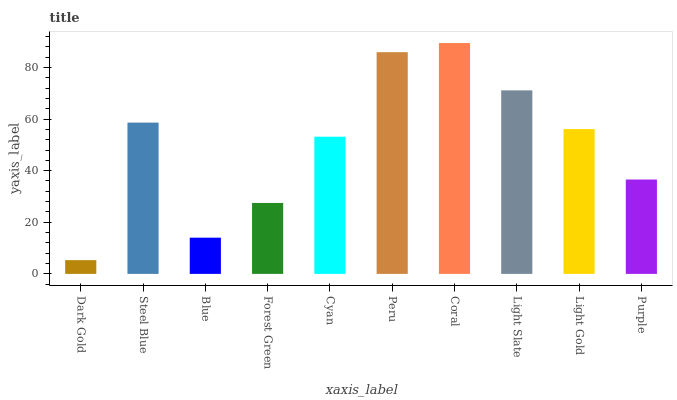Is Steel Blue the minimum?
Answer yes or no. No. Is Steel Blue the maximum?
Answer yes or no. No. Is Steel Blue greater than Dark Gold?
Answer yes or no. Yes. Is Dark Gold less than Steel Blue?
Answer yes or no. Yes. Is Dark Gold greater than Steel Blue?
Answer yes or no. No. Is Steel Blue less than Dark Gold?
Answer yes or no. No. Is Light Gold the high median?
Answer yes or no. Yes. Is Cyan the low median?
Answer yes or no. Yes. Is Coral the high median?
Answer yes or no. No. Is Purple the low median?
Answer yes or no. No. 